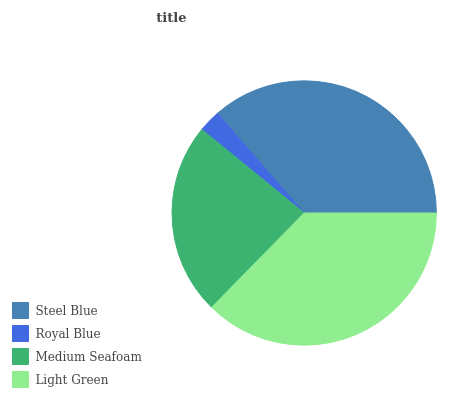Is Royal Blue the minimum?
Answer yes or no. Yes. Is Light Green the maximum?
Answer yes or no. Yes. Is Medium Seafoam the minimum?
Answer yes or no. No. Is Medium Seafoam the maximum?
Answer yes or no. No. Is Medium Seafoam greater than Royal Blue?
Answer yes or no. Yes. Is Royal Blue less than Medium Seafoam?
Answer yes or no. Yes. Is Royal Blue greater than Medium Seafoam?
Answer yes or no. No. Is Medium Seafoam less than Royal Blue?
Answer yes or no. No. Is Steel Blue the high median?
Answer yes or no. Yes. Is Medium Seafoam the low median?
Answer yes or no. Yes. Is Royal Blue the high median?
Answer yes or no. No. Is Royal Blue the low median?
Answer yes or no. No. 